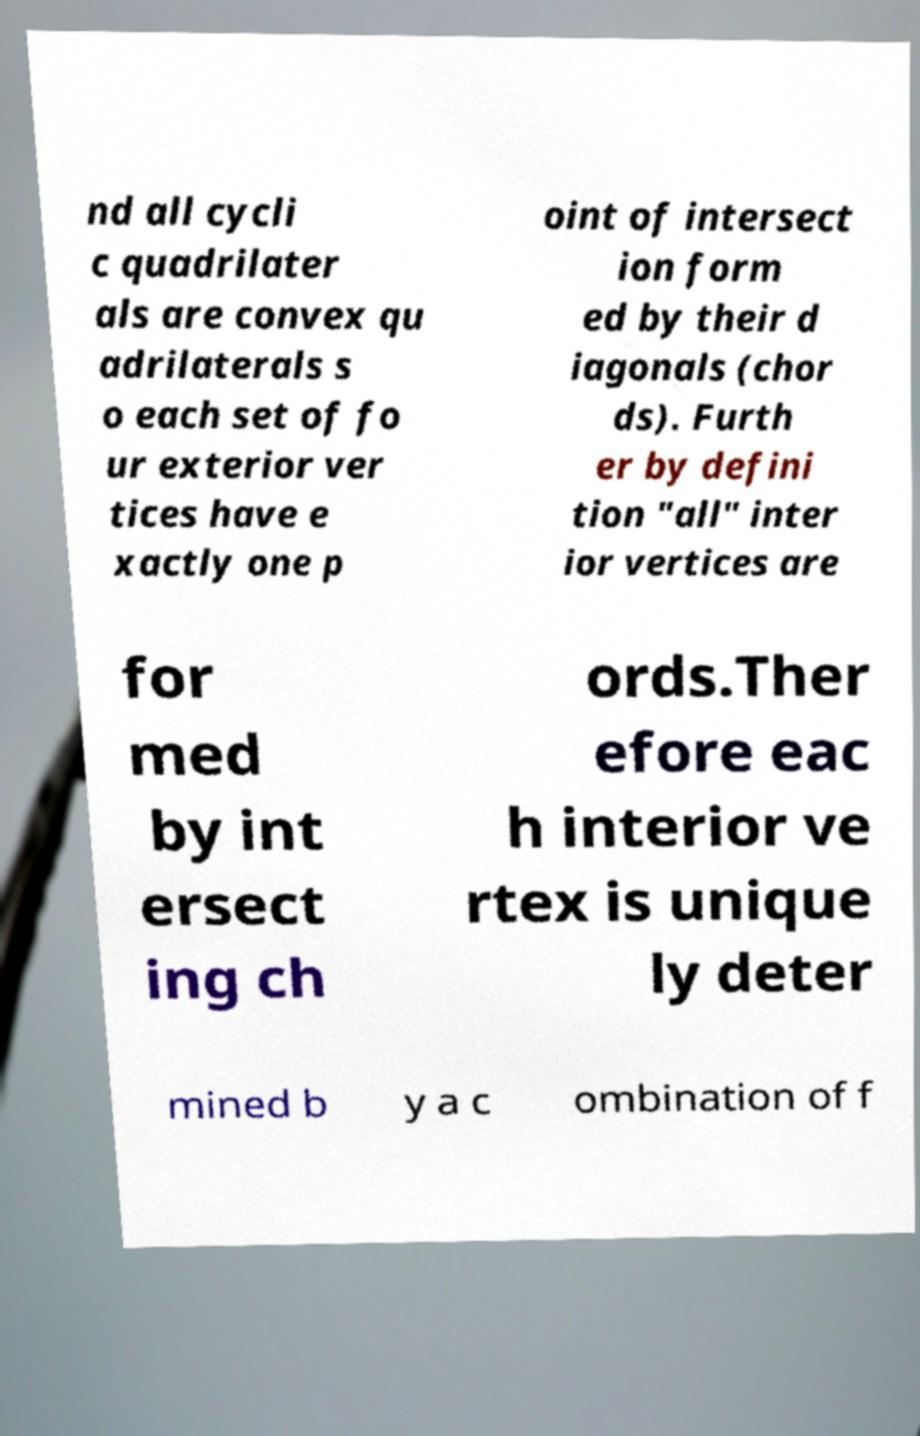There's text embedded in this image that I need extracted. Can you transcribe it verbatim? nd all cycli c quadrilater als are convex qu adrilaterals s o each set of fo ur exterior ver tices have e xactly one p oint of intersect ion form ed by their d iagonals (chor ds). Furth er by defini tion "all" inter ior vertices are for med by int ersect ing ch ords.Ther efore eac h interior ve rtex is unique ly deter mined b y a c ombination of f 